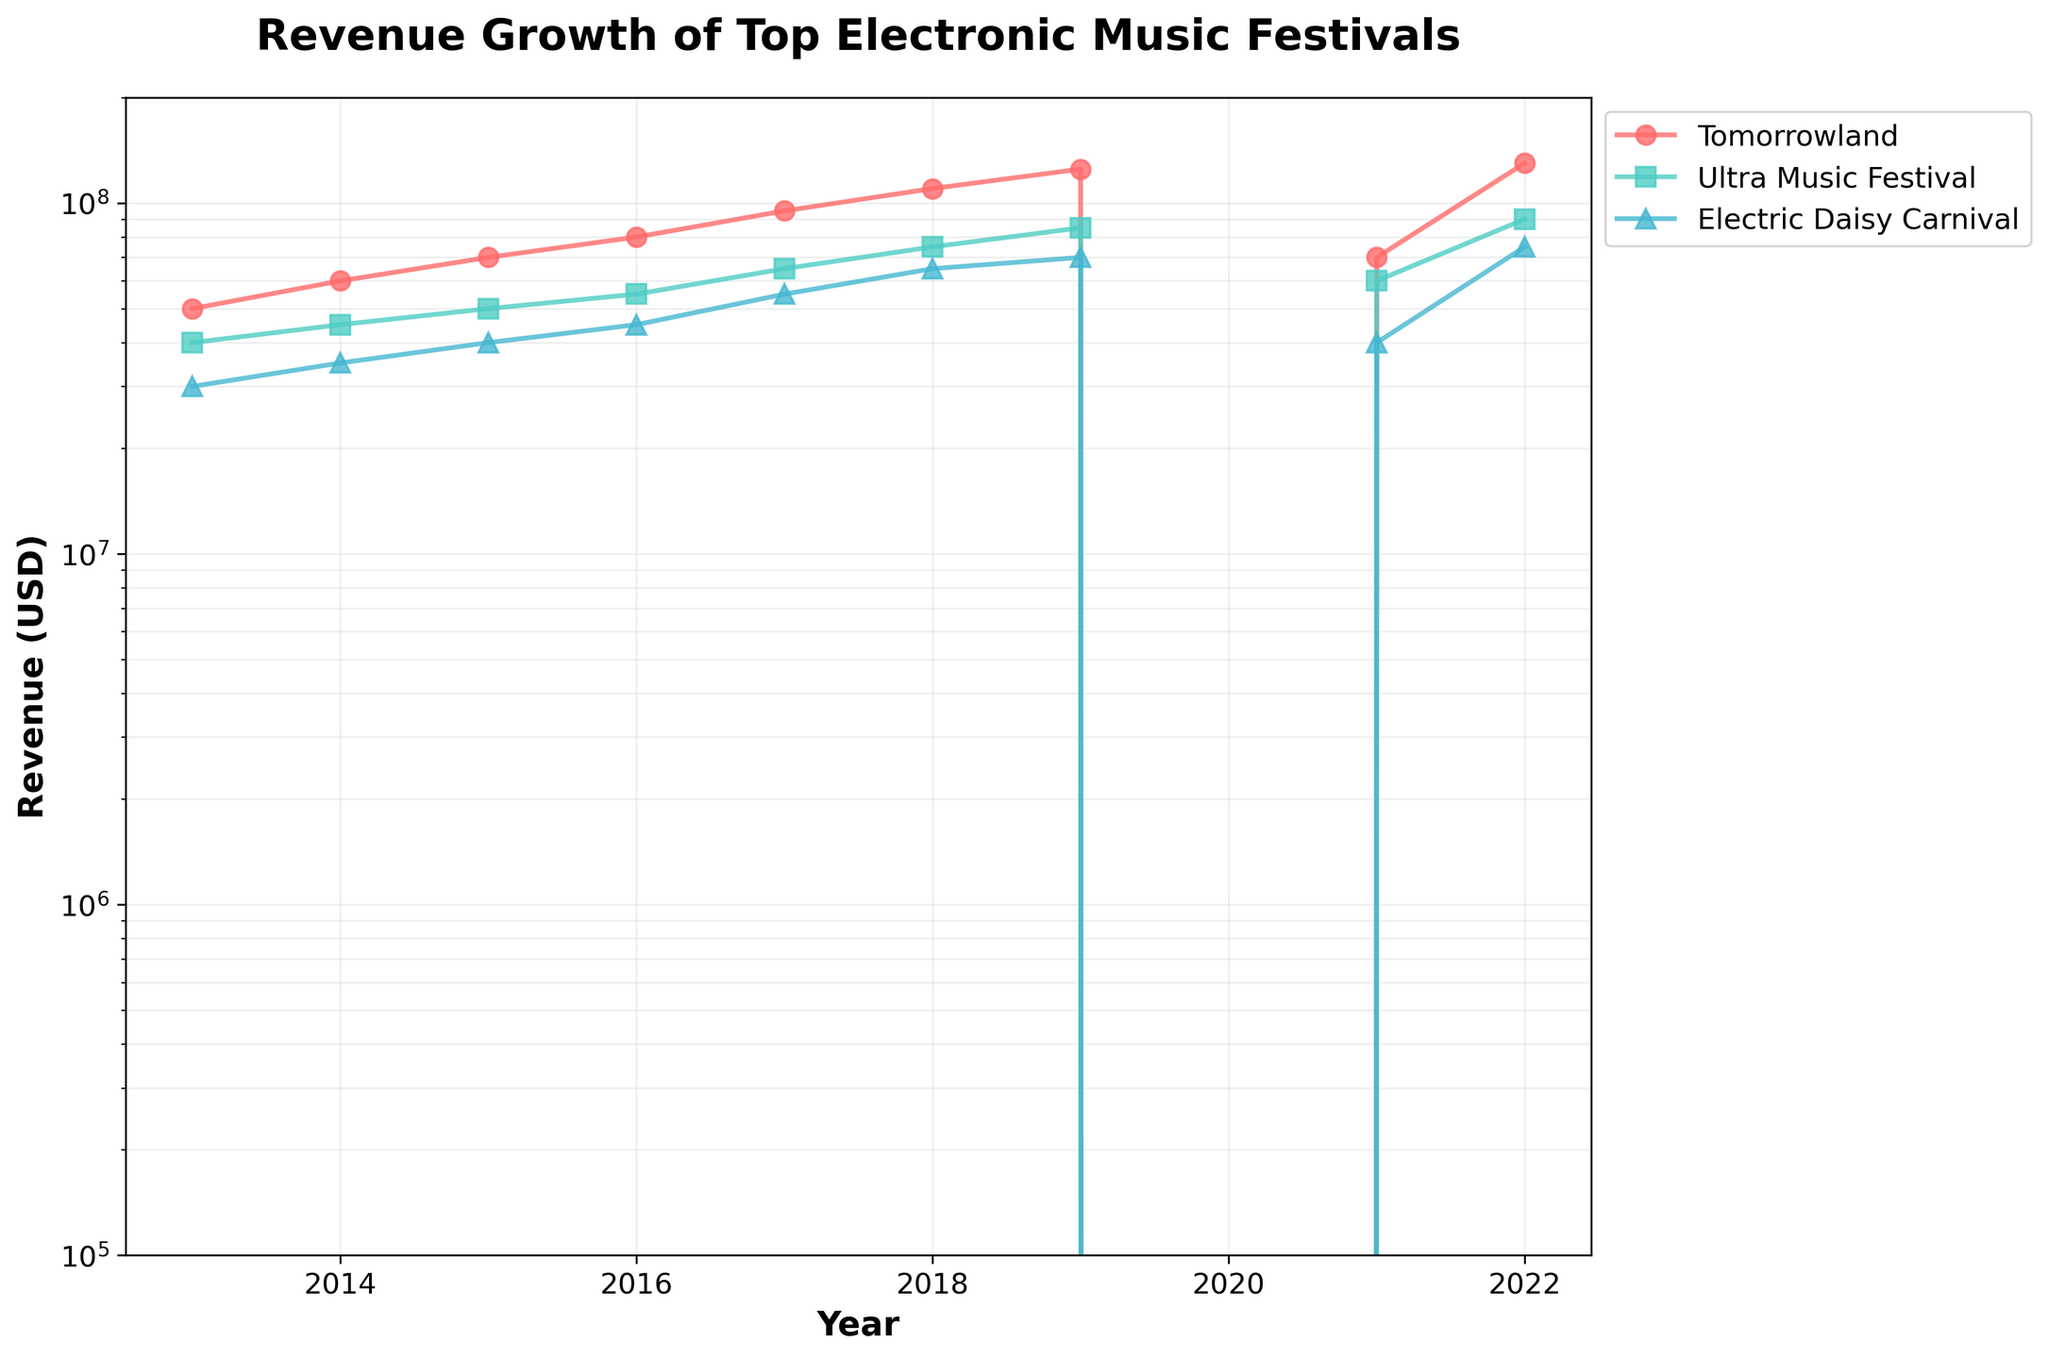What is the title of the figure? The title is usually found at the top of the figure. In this figure, the title is prominently displayed.
Answer: Revenue Growth of Top Electronic Music Festivals What is the y-axis scale? The y-axis scale is indicated on the left side of the figure. Observing the axis labels and spacing of values can reveal the logarithmic scale.
Answer: Logarithmic Which festival had the highest revenue in 2022? By examining the data points for the year 2022 and comparing the heights of the lines, the highest point corresponds to the highest revenue. The festival with the highest point for 2022 is Tomorrowland.
Answer: Tomorrowland How did the revenue of Tomorrowland change in 2020? Look at the data point for Tomorrowland in the year 2020. The plot shows a sharp drop to the lowest position in the graph, indicating no revenue.
Answer: It dropped to zero Compare the revenue growth of Ultra Music Festival and Electric Daisy Carnival from 2013 to 2019. Which festival experienced more growth? Calculate the difference between 2019 and 2013 revenues for both festivals: Ultra (85000000 - 40000000) = 45000000 and Electric Daisy Carnival (70000000 - 30000000) = 40000000. Ultra Music Festival experienced more revenue growth.
Answer: Ultra Music Festival What happened to the revenues of all three festivals in the year 2020? All three lines show data points dropping to the bottom of the graph in 2020, indicating the same trend of having no revenue.
Answer: They all dropped to zero Which festival rebounded the most in 2021 after the dip in 2020? Compare the increase from 2020 to 2021 for all festivals: Tomorrowland ($70,000,000), Ultra Music Festival ($60,000,000), and Electric Daisy Carnival ($40,000,000). Tomorrowland has the highest rebound.
Answer: Tomorrowland What was the average revenue of Tomorrowland from 2013 to 2019? Sum the revenues from 2013 to 2019 (50M+60M+70M+80M+95M+110M+125M=590M) and divide by the number of years (7). 590M / 7 = 84.2857M
Answer: 84.2857M In which year did Electric Daisy Carnival surpass $50 million in revenue for the first time? Identify the first year in the plot where Electric Daisy Carnival's revenue exceeds the halfway point between $10 million (10^7) and $100 million (10^8). This occurs in 2017.
Answer: 2017 